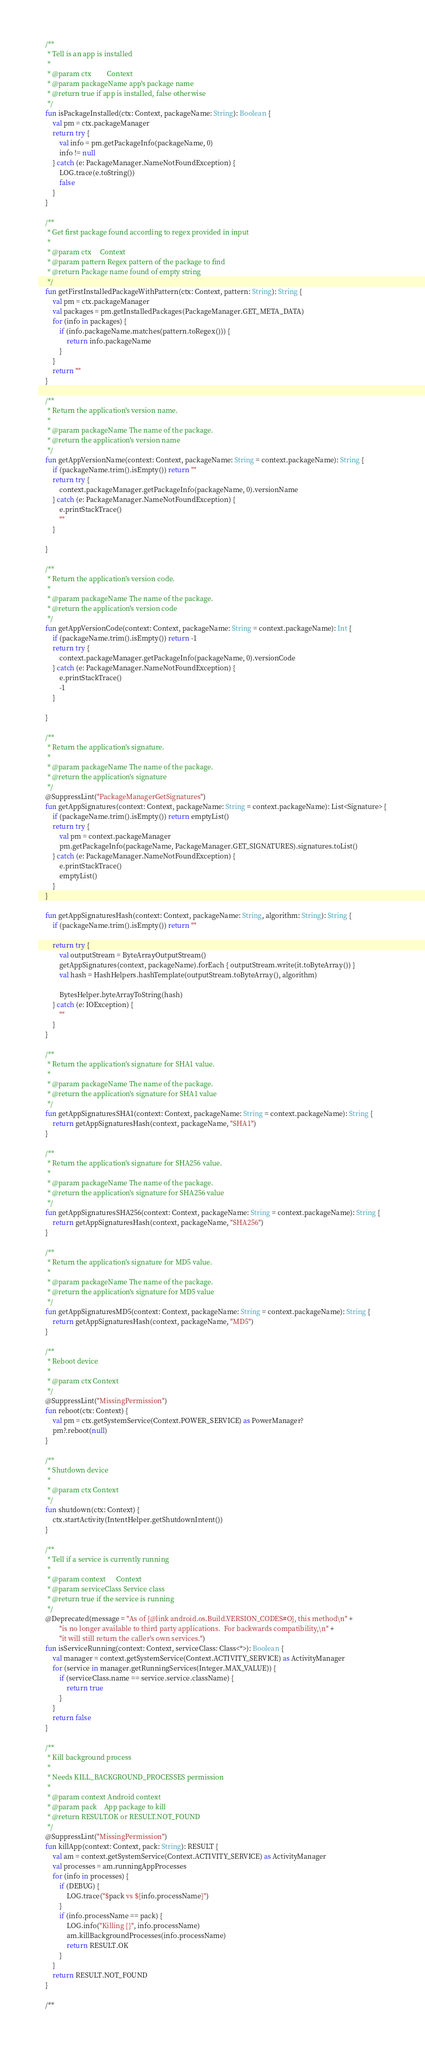Convert code to text. <code><loc_0><loc_0><loc_500><loc_500><_Kotlin_>
    /**
     * Tell is an app is installed
     *
     * @param ctx         Context
     * @param packageName app's package name
     * @return true if app is installed, false otherwise
     */
    fun isPackageInstalled(ctx: Context, packageName: String): Boolean {
        val pm = ctx.packageManager
        return try {
            val info = pm.getPackageInfo(packageName, 0)
            info != null
        } catch (e: PackageManager.NameNotFoundException) {
            LOG.trace(e.toString())
            false
        }
    }

    /**
     * Get first package found according to regex provided in input
     *
     * @param ctx     Context
     * @param pattern Regex pattern of the package to find
     * @return Package name found of empty string
     */
    fun getFirstInstalledPackageWithPattern(ctx: Context, pattern: String): String {
        val pm = ctx.packageManager
        val packages = pm.getInstalledPackages(PackageManager.GET_META_DATA)
        for (info in packages) {
            if (info.packageName.matches(pattern.toRegex())) {
                return info.packageName
            }
        }
        return ""
    }

    /**
     * Return the application's version name.
     *
     * @param packageName The name of the package.
     * @return the application's version name
     */
    fun getAppVersionName(context: Context, packageName: String = context.packageName): String {
        if (packageName.trim().isEmpty()) return ""
        return try {
            context.packageManager.getPackageInfo(packageName, 0).versionName
        } catch (e: PackageManager.NameNotFoundException) {
            e.printStackTrace()
            ""
        }

    }

    /**
     * Return the application's version code.
     *
     * @param packageName The name of the package.
     * @return the application's version code
     */
    fun getAppVersionCode(context: Context, packageName: String = context.packageName): Int {
        if (packageName.trim().isEmpty()) return -1
        return try {
            context.packageManager.getPackageInfo(packageName, 0).versionCode
        } catch (e: PackageManager.NameNotFoundException) {
            e.printStackTrace()
            -1
        }

    }

    /**
     * Return the application's signature.
     *
     * @param packageName The name of the package.
     * @return the application's signature
     */
    @SuppressLint("PackageManagerGetSignatures")
    fun getAppSignatures(context: Context, packageName: String = context.packageName): List<Signature> {
        if (packageName.trim().isEmpty()) return emptyList()
        return try {
            val pm = context.packageManager
            pm.getPackageInfo(packageName, PackageManager.GET_SIGNATURES).signatures.toList()
        } catch (e: PackageManager.NameNotFoundException) {
            e.printStackTrace()
            emptyList()
        }
    }

    fun getAppSignaturesHash(context: Context, packageName: String, algorithm: String): String {
        if (packageName.trim().isEmpty()) return ""

        return try {
            val outputStream = ByteArrayOutputStream()
            getAppSignatures(context, packageName).forEach { outputStream.write(it.toByteArray()) }
            val hash = HashHelpers.hashTemplate(outputStream.toByteArray(), algorithm)

            BytesHelper.byteArrayToString(hash)
        } catch (e: IOException) {
            ""
        }
    }

    /**
     * Return the application's signature for SHA1 value.
     *
     * @param packageName The name of the package.
     * @return the application's signature for SHA1 value
     */
    fun getAppSignaturesSHA1(context: Context, packageName: String = context.packageName): String {
        return getAppSignaturesHash(context, packageName, "SHA1")
    }

    /**
     * Return the application's signature for SHA256 value.
     *
     * @param packageName The name of the package.
     * @return the application's signature for SHA256 value
     */
    fun getAppSignaturesSHA256(context: Context, packageName: String = context.packageName): String {
        return getAppSignaturesHash(context, packageName, "SHA256")
    }

    /**
     * Return the application's signature for MD5 value.
     *
     * @param packageName The name of the package.
     * @return the application's signature for MD5 value
     */
    fun getAppSignaturesMD5(context: Context, packageName: String = context.packageName): String {
        return getAppSignaturesHash(context, packageName, "MD5")
    }

    /**
     * Reboot device
     *
     * @param ctx Context
     */
    @SuppressLint("MissingPermission")
    fun reboot(ctx: Context) {
        val pm = ctx.getSystemService(Context.POWER_SERVICE) as PowerManager?
        pm?.reboot(null)
    }

    /**
     * Shutdown device
     *
     * @param ctx Context
     */
    fun shutdown(ctx: Context) {
        ctx.startActivity(IntentHelper.getShutdownIntent())
    }

    /**
     * Tell if a service is currently running
     *
     * @param context      Context
     * @param serviceClass Service class
     * @return true if the service is running
     */
    @Deprecated(message = "As of {@link android.os.Build.VERSION_CODES#O}, this method\n" +
            "is no longer available to third party applications.  For backwards compatibility,\n" +
            "it will still return the caller's own services.")
    fun isServiceRunning(context: Context, serviceClass: Class<*>): Boolean {
        val manager = context.getSystemService(Context.ACTIVITY_SERVICE) as ActivityManager
        for (service in manager.getRunningServices(Integer.MAX_VALUE)) {
            if (serviceClass.name == service.service.className) {
                return true
            }
        }
        return false
    }

    /**
     * Kill background process
     *
     * Needs KILL_BACKGROUND_PROCESSES permission
     *
     * @param context Android context
     * @param pack    App package to kill
     * @return RESULT.OK or RESULT.NOT_FOUND
     */
    @SuppressLint("MissingPermission")
    fun killApp(context: Context, pack: String): RESULT {
        val am = context.getSystemService(Context.ACTIVITY_SERVICE) as ActivityManager
        val processes = am.runningAppProcesses
        for (info in processes) {
            if (DEBUG) {
                LOG.trace("$pack vs ${info.processName}")
            }
            if (info.processName == pack) {
                LOG.info("Killing {}", info.processName)
                am.killBackgroundProcesses(info.processName)
                return RESULT.OK
            }
        }
        return RESULT.NOT_FOUND
    }

    /**</code> 